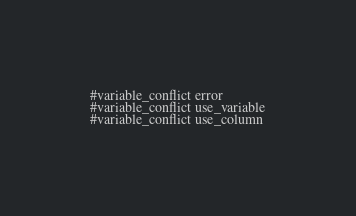<code> <loc_0><loc_0><loc_500><loc_500><_SQL_>#variable_conflict error
#variable_conflict use_variable
#variable_conflict use_column
</code> 